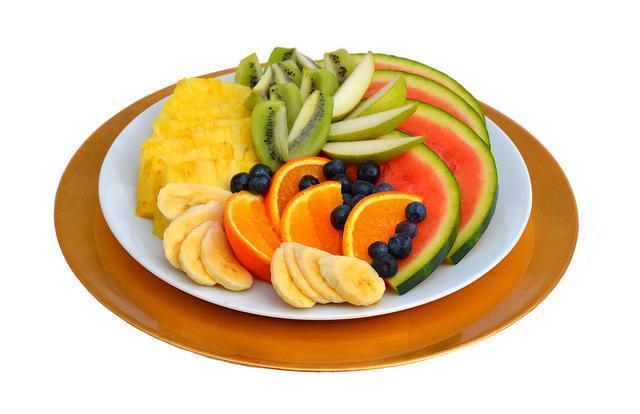How many different fruits on the plate?
Give a very brief answer. 7. How many crackers are in the photo?
Give a very brief answer. 0. How many oranges can you see?
Give a very brief answer. 4. How many bananas can be seen?
Give a very brief answer. 2. 